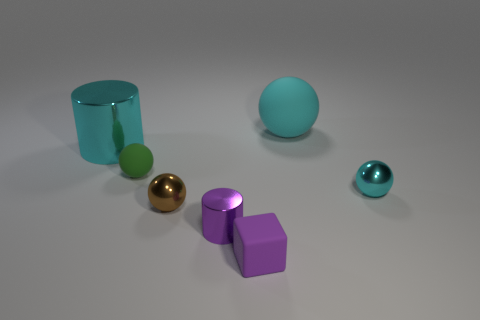How many other objects are there of the same color as the tiny cube?
Provide a succinct answer. 1. There is a matte ball that is behind the cyan metallic cylinder; does it have the same color as the large metal object?
Give a very brief answer. Yes. There is another metal object that is the same color as the big metallic object; what is its size?
Offer a terse response. Small. Is the color of the big metal thing the same as the big rubber thing?
Provide a succinct answer. Yes. Is there a metallic ball that has the same color as the big metallic cylinder?
Provide a succinct answer. Yes. There is a small block; is it the same color as the cylinder that is in front of the small cyan ball?
Keep it short and to the point. Yes. Is the number of big cylinders that are in front of the purple rubber cube the same as the number of large metal cubes?
Give a very brief answer. Yes. What shape is the object that is in front of the big cyan sphere and right of the small purple cube?
Provide a succinct answer. Sphere. There is another big metal thing that is the same shape as the purple metal thing; what color is it?
Give a very brief answer. Cyan. Is there anything else that has the same color as the tiny matte ball?
Your answer should be very brief. No. 